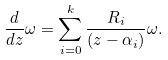Convert formula to latex. <formula><loc_0><loc_0><loc_500><loc_500>\frac { d } { d z } \omega = \sum _ { i = 0 } ^ { k } \frac { R _ { i } } { ( z - \alpha _ { i } ) } \omega .</formula> 